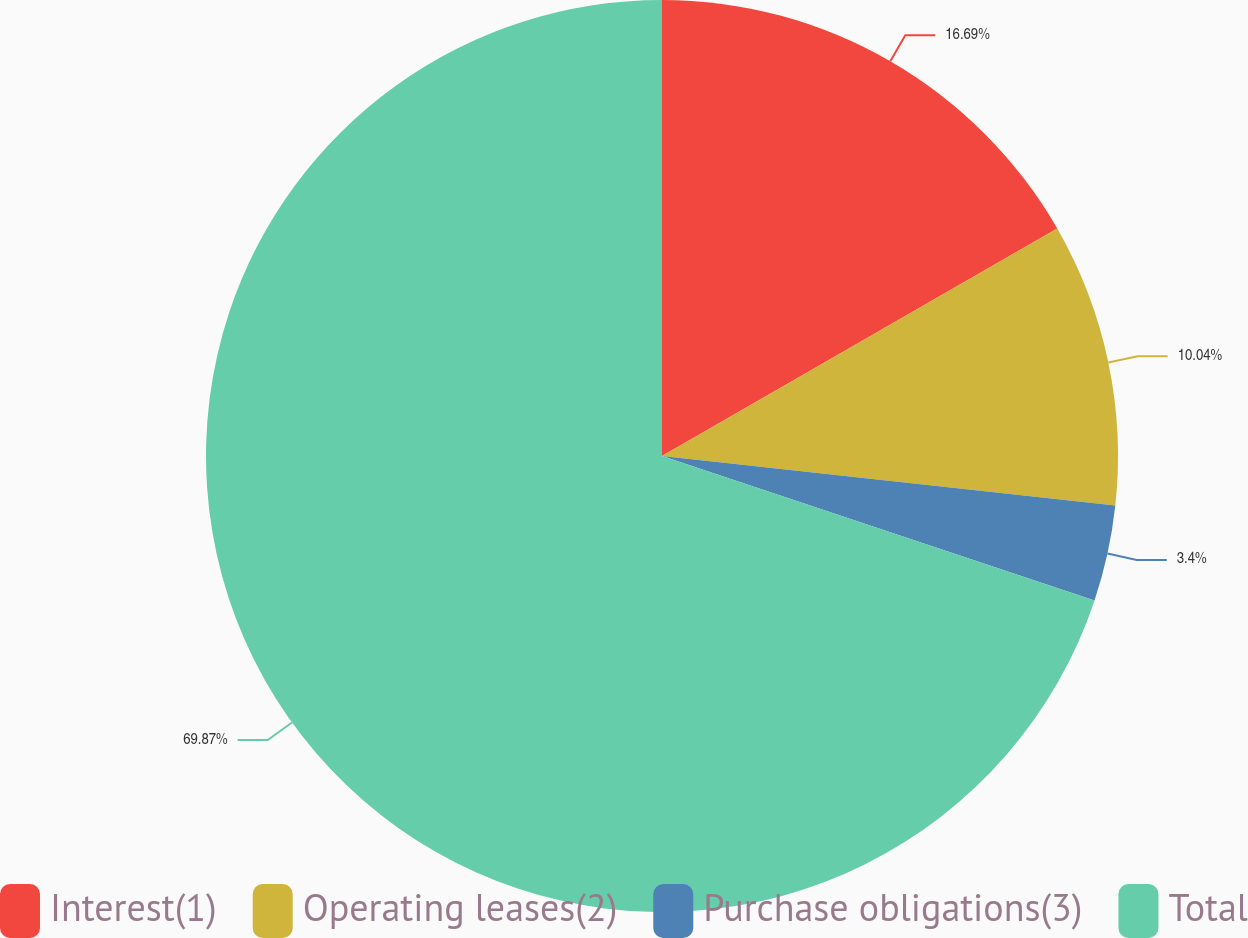Convert chart to OTSL. <chart><loc_0><loc_0><loc_500><loc_500><pie_chart><fcel>Interest(1)<fcel>Operating leases(2)<fcel>Purchase obligations(3)<fcel>Total<nl><fcel>16.69%<fcel>10.04%<fcel>3.4%<fcel>69.87%<nl></chart> 